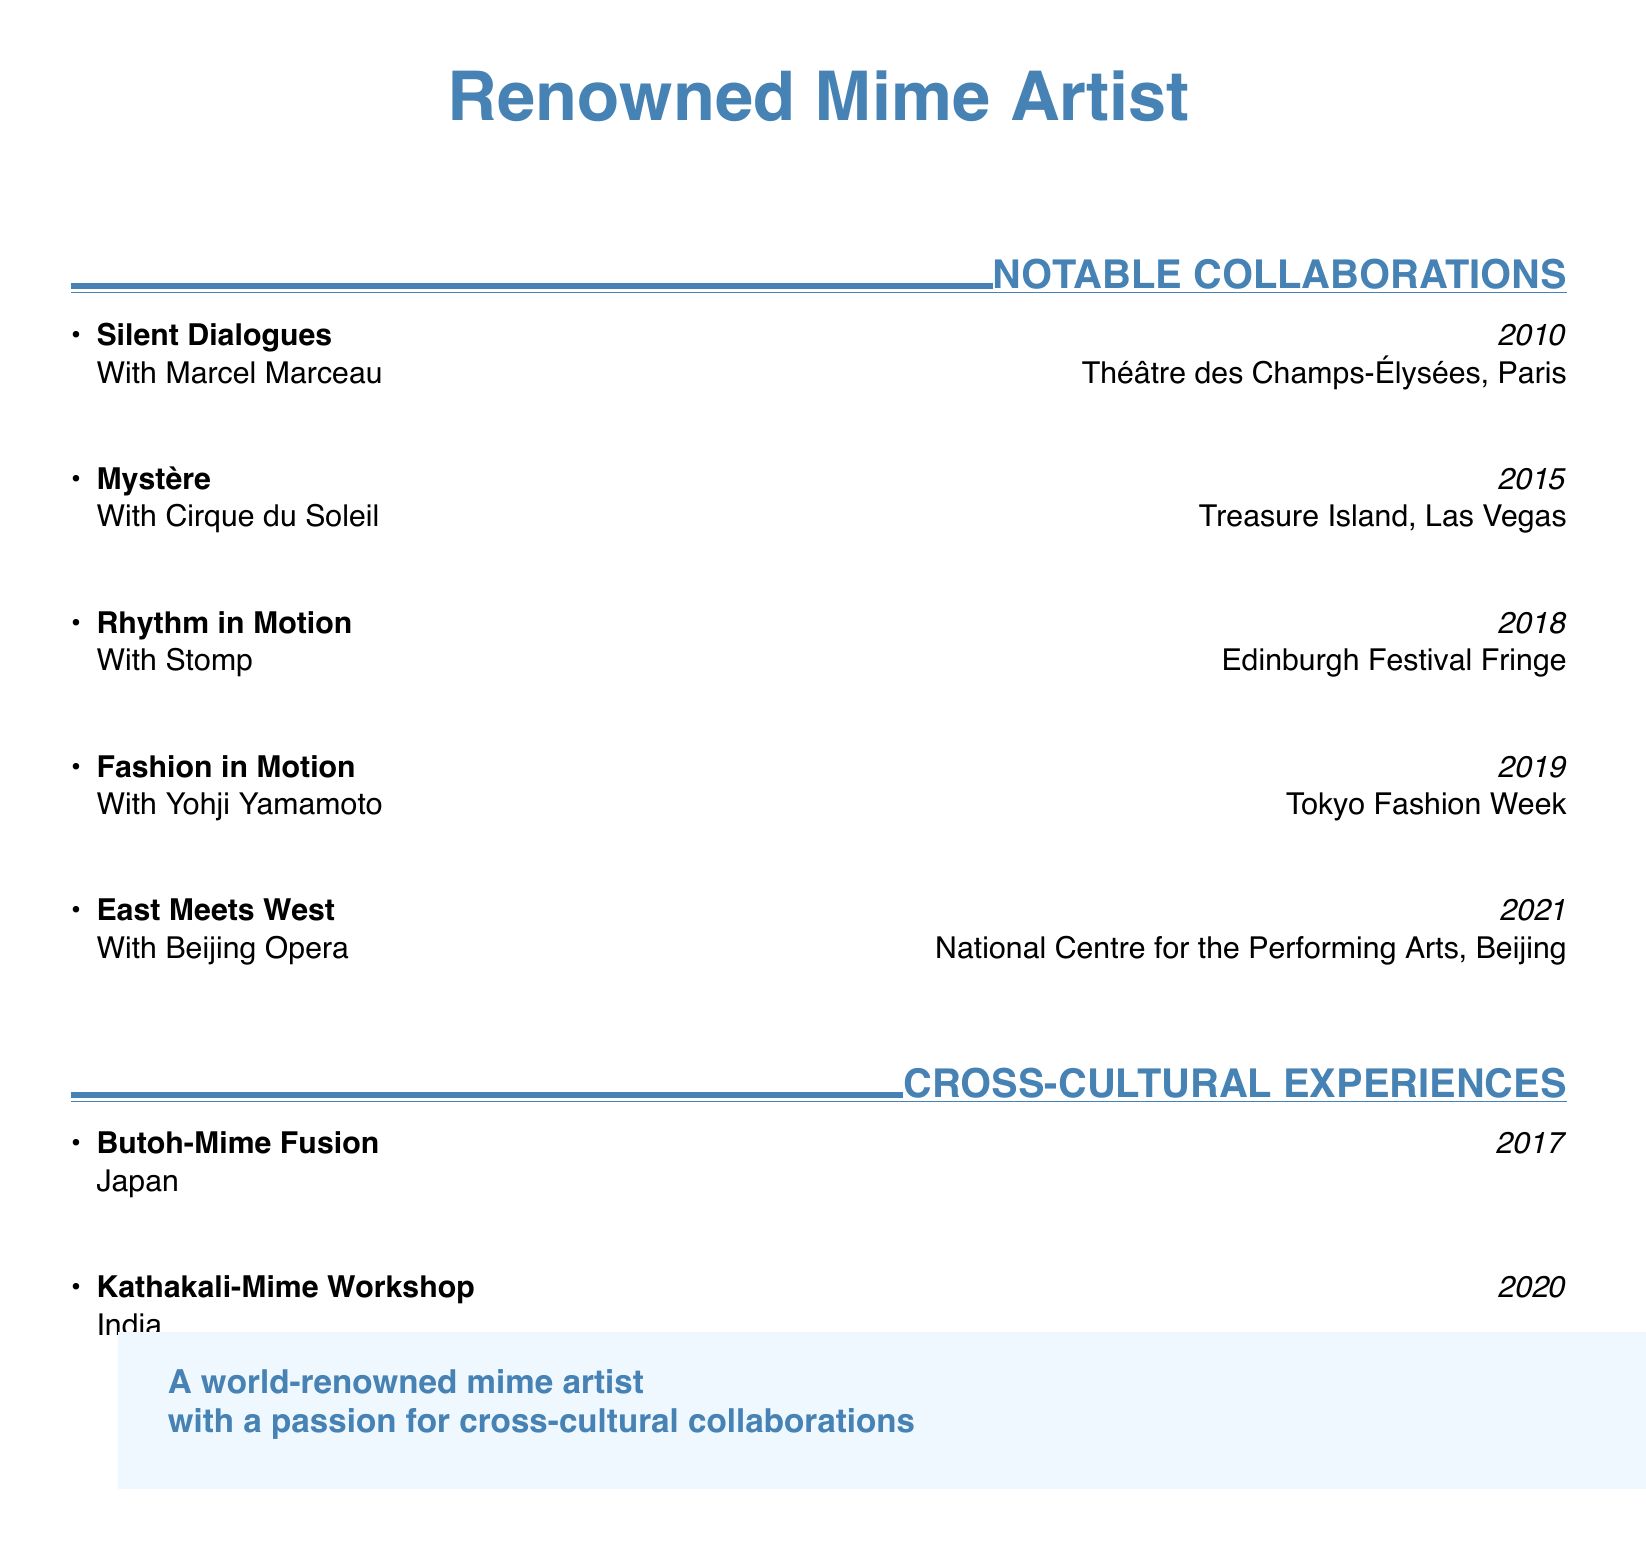What was the project with Marcel Marceau? The project is "Silent Dialogues."
Answer: Silent Dialogues In which year did the collaboration with Cirque du Soleil take place? The collaboration occurred in 2015.
Answer: 2015 What venue hosted the "Rhythm in Motion" project? "Rhythm in Motion" was held at the Edinburgh Festival Fringe.
Answer: Edinburgh Festival Fringe Which country was involved in the "Butoh-Mime Fusion" project? The country involved was Japan.
Answer: Japan How many notable collaborations are listed in the document? There are five notable collaborations mentioned.
Answer: 5 What is the name of the project performed with the Beijing Opera? The project is called "East Meets West."
Answer: East Meets West What year did the "Kathakali-Mime Workshop" take place? The workshop took place in 2020.
Answer: 2020 Which fashion designer collaborated in 2019? The designer is Yohji Yamamoto.
Answer: Yohji Yamamoto What is the overarching theme of the collaboration section? The theme emphasizes cross-cultural experiences in performing arts.
Answer: Cross-cultural experiences 